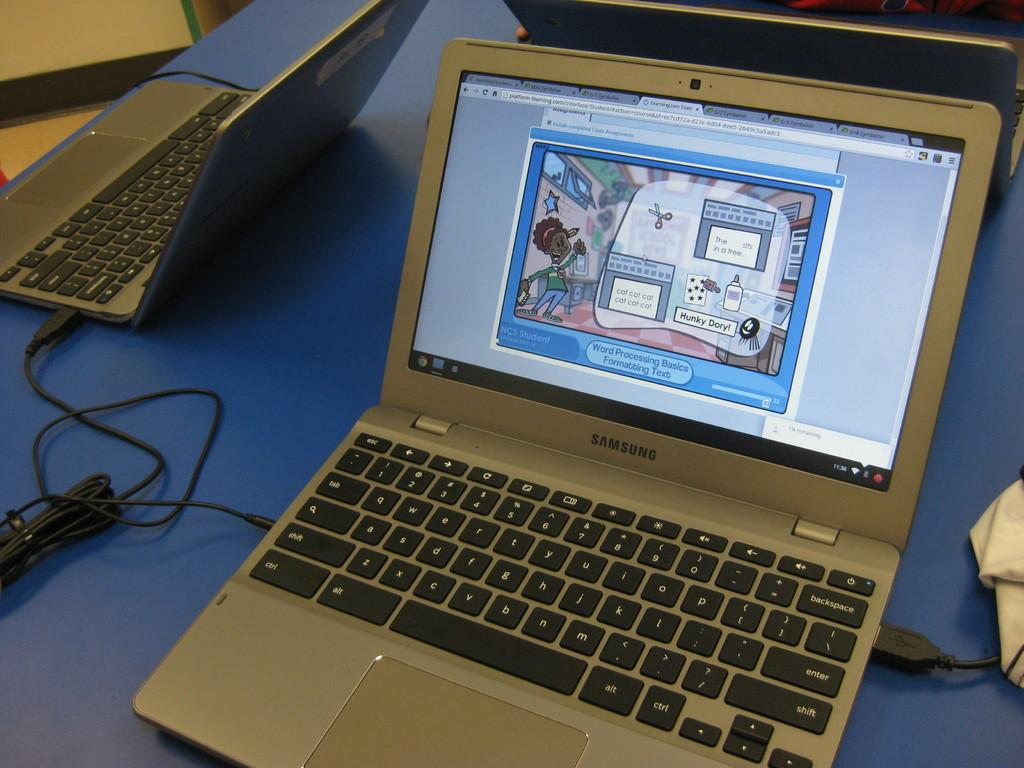<image>
Present a compact description of the photo's key features. Computer laptop with a screen that shows the phrase "Hunky Dory!". 